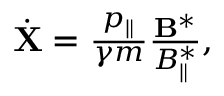Convert formula to latex. <formula><loc_0><loc_0><loc_500><loc_500>\begin{array} { r } { \dot { X } = \frac { p _ { \| } } { \gamma m } \frac { { B } ^ { * } } { B _ { \| } ^ { * } } , } \end{array}</formula> 